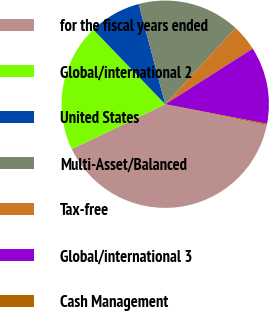Convert chart. <chart><loc_0><loc_0><loc_500><loc_500><pie_chart><fcel>for the fiscal years ended<fcel>Global/international 2<fcel>United States<fcel>Multi-Asset/Balanced<fcel>Tax-free<fcel>Global/international 3<fcel>Cash Management<nl><fcel>39.65%<fcel>19.92%<fcel>8.09%<fcel>15.98%<fcel>4.14%<fcel>12.03%<fcel>0.2%<nl></chart> 